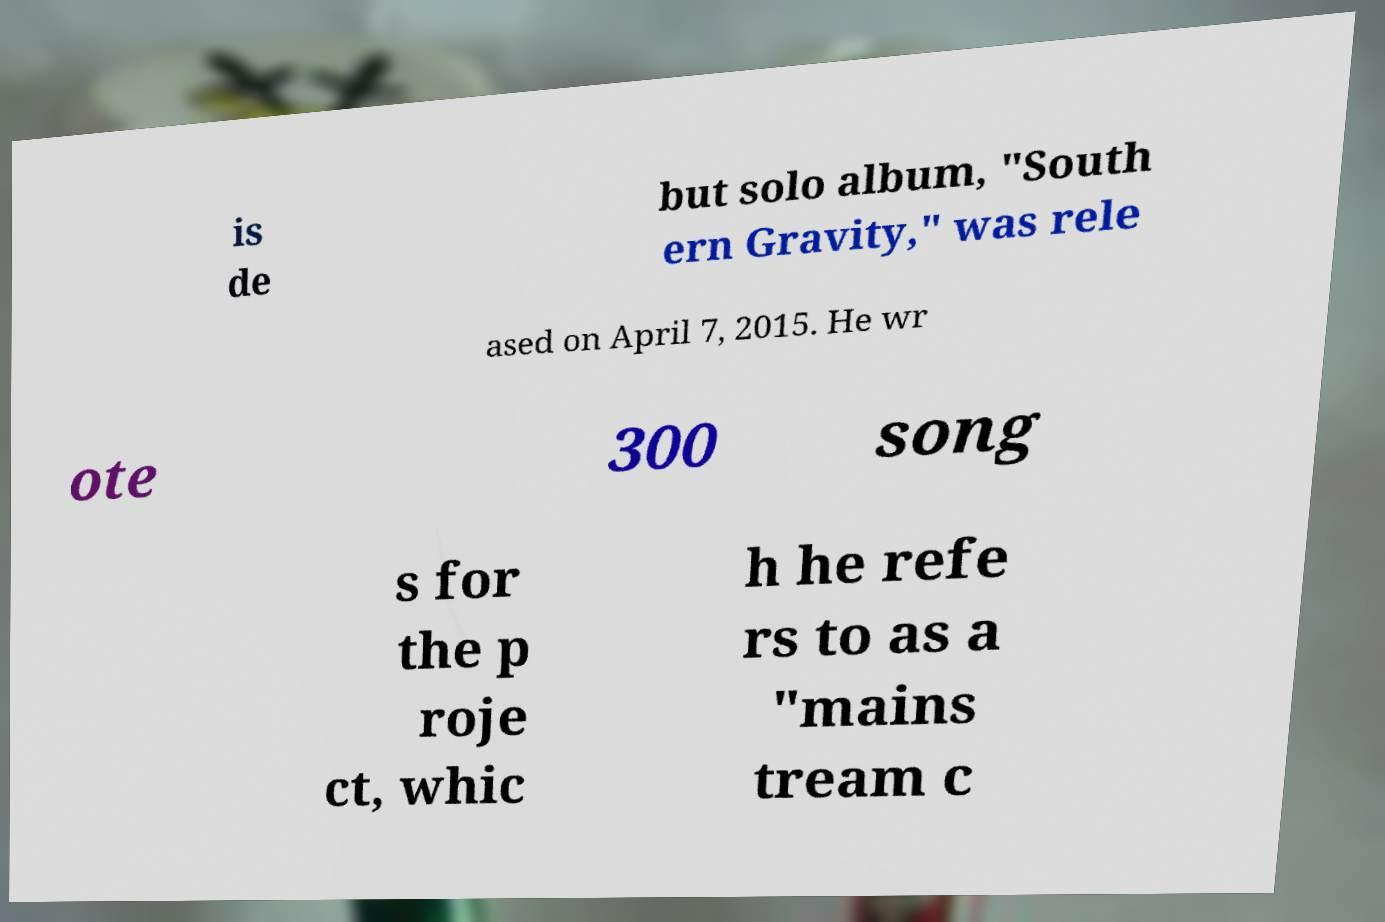Can you read and provide the text displayed in the image?This photo seems to have some interesting text. Can you extract and type it out for me? is de but solo album, "South ern Gravity," was rele ased on April 7, 2015. He wr ote 300 song s for the p roje ct, whic h he refe rs to as a "mains tream c 